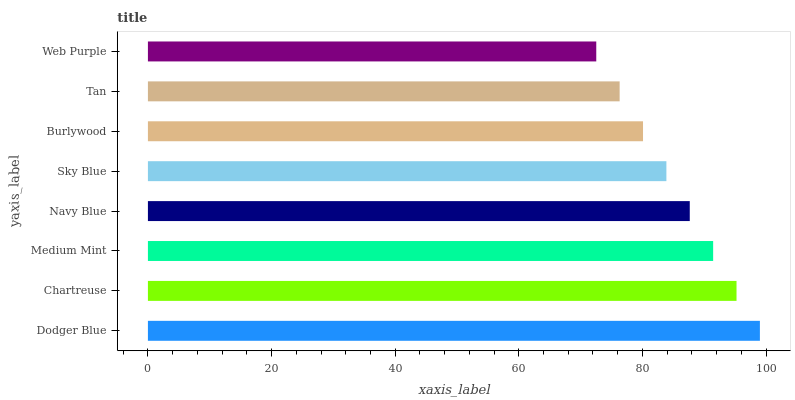Is Web Purple the minimum?
Answer yes or no. Yes. Is Dodger Blue the maximum?
Answer yes or no. Yes. Is Chartreuse the minimum?
Answer yes or no. No. Is Chartreuse the maximum?
Answer yes or no. No. Is Dodger Blue greater than Chartreuse?
Answer yes or no. Yes. Is Chartreuse less than Dodger Blue?
Answer yes or no. Yes. Is Chartreuse greater than Dodger Blue?
Answer yes or no. No. Is Dodger Blue less than Chartreuse?
Answer yes or no. No. Is Navy Blue the high median?
Answer yes or no. Yes. Is Sky Blue the low median?
Answer yes or no. Yes. Is Burlywood the high median?
Answer yes or no. No. Is Web Purple the low median?
Answer yes or no. No. 